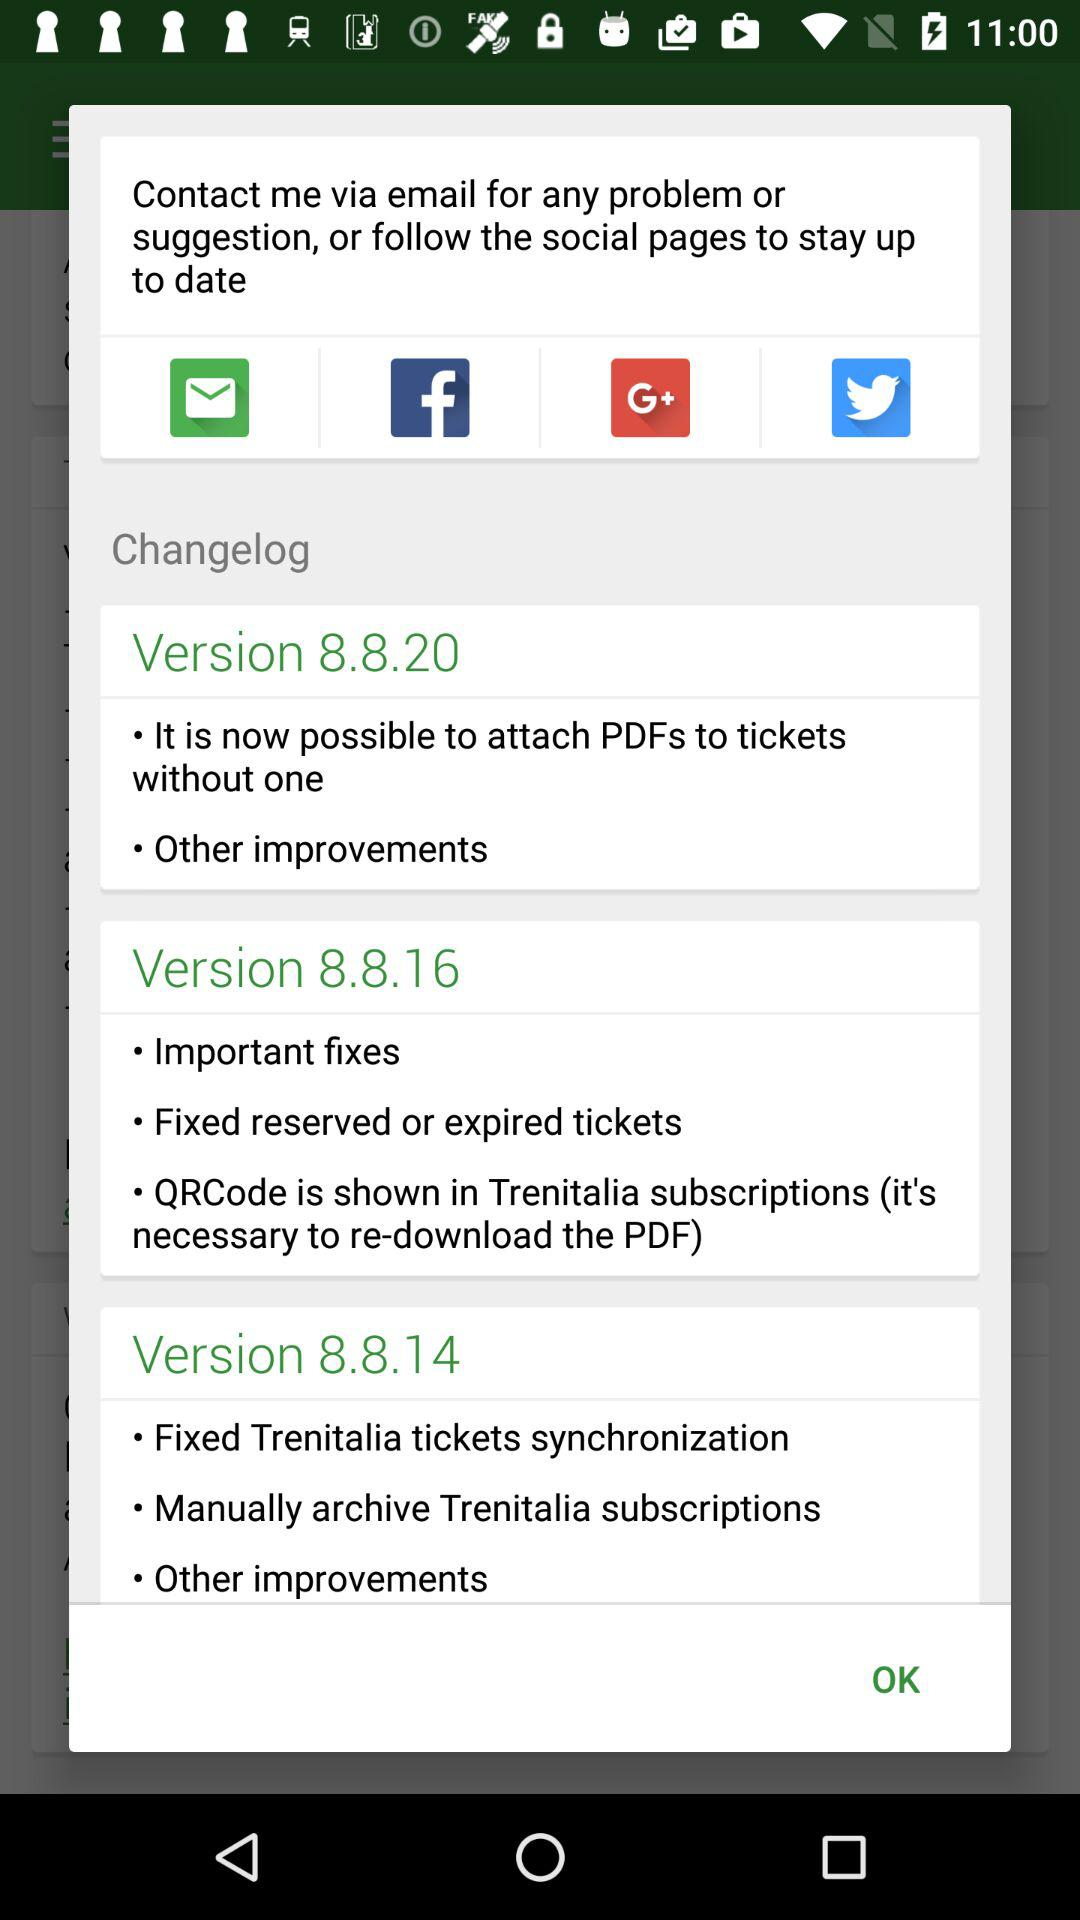What are the features of version 8.8.16? The features of version 8.8.16 are "Important fixes", "Fixed reserved or expired tickets" and "QRCode is shown in Trenitalia subscriptions (it's necessary to re-download the PDF)". 